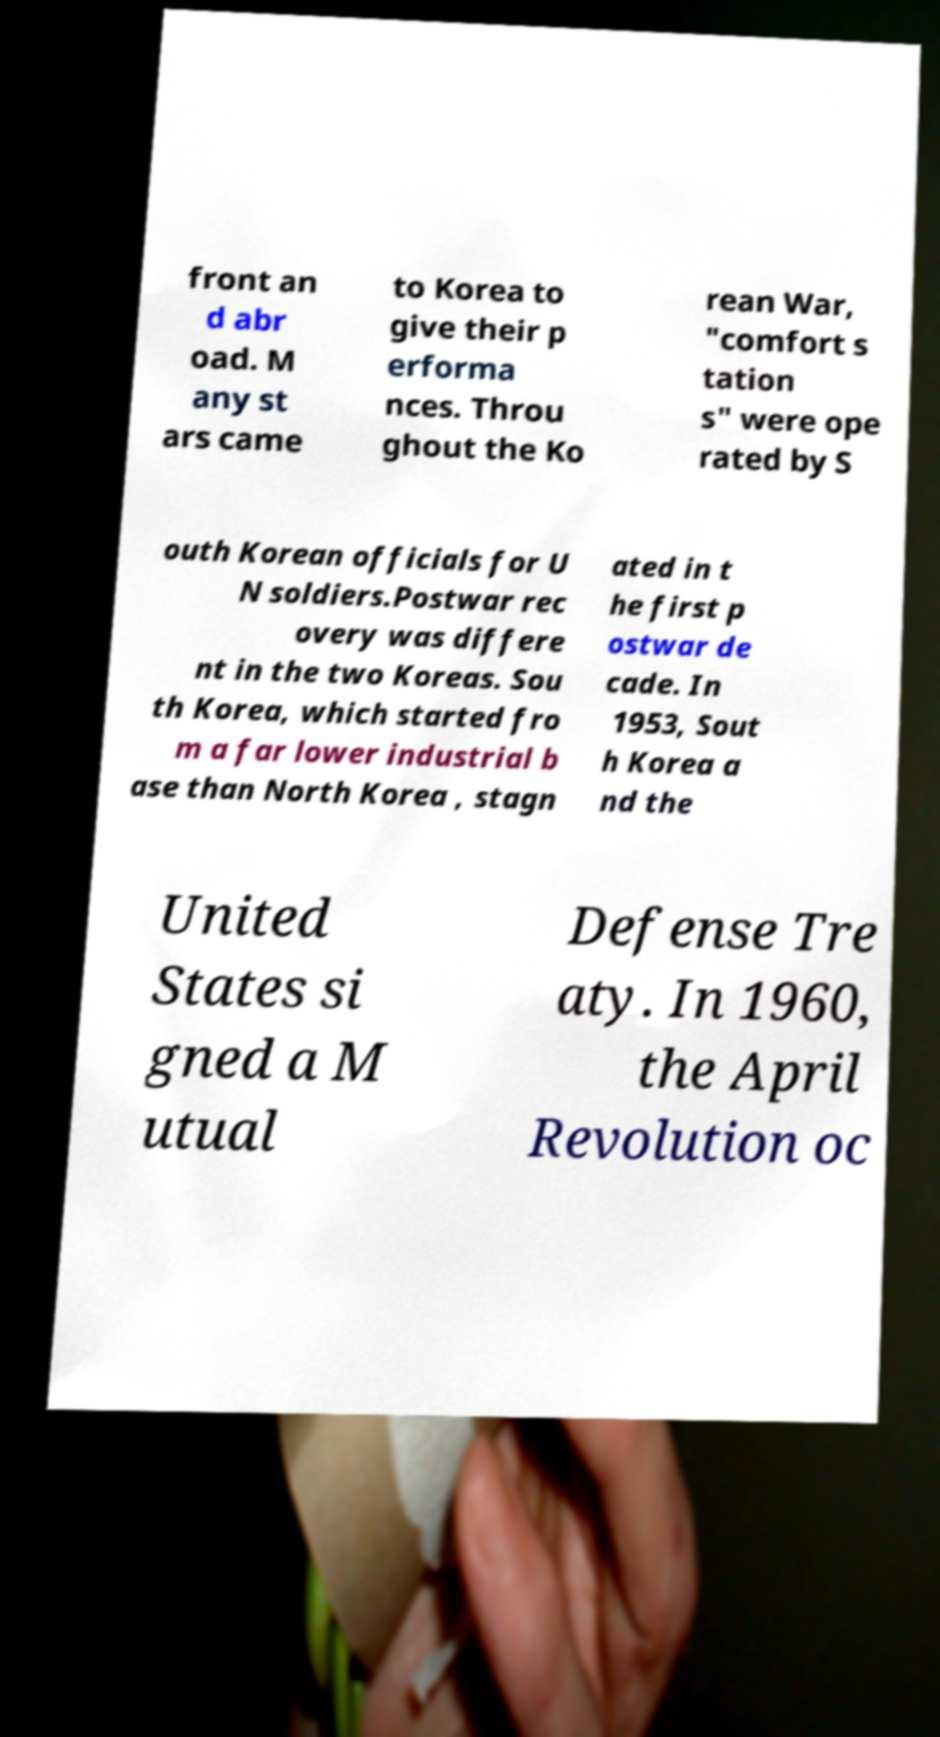What messages or text are displayed in this image? I need them in a readable, typed format. front an d abr oad. M any st ars came to Korea to give their p erforma nces. Throu ghout the Ko rean War, "comfort s tation s" were ope rated by S outh Korean officials for U N soldiers.Postwar rec overy was differe nt in the two Koreas. Sou th Korea, which started fro m a far lower industrial b ase than North Korea , stagn ated in t he first p ostwar de cade. In 1953, Sout h Korea a nd the United States si gned a M utual Defense Tre aty. In 1960, the April Revolution oc 